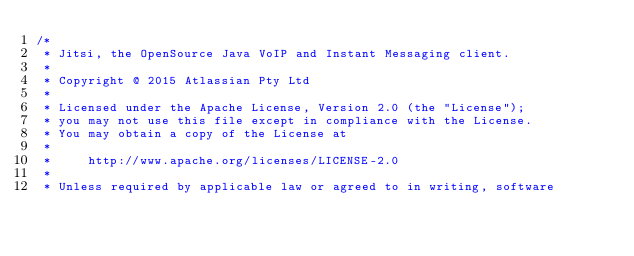Convert code to text. <code><loc_0><loc_0><loc_500><loc_500><_Java_>/*
 * Jitsi, the OpenSource Java VoIP and Instant Messaging client.
 *
 * Copyright @ 2015 Atlassian Pty Ltd
 *
 * Licensed under the Apache License, Version 2.0 (the "License");
 * you may not use this file except in compliance with the License.
 * You may obtain a copy of the License at
 *
 *     http://www.apache.org/licenses/LICENSE-2.0
 *
 * Unless required by applicable law or agreed to in writing, software</code> 